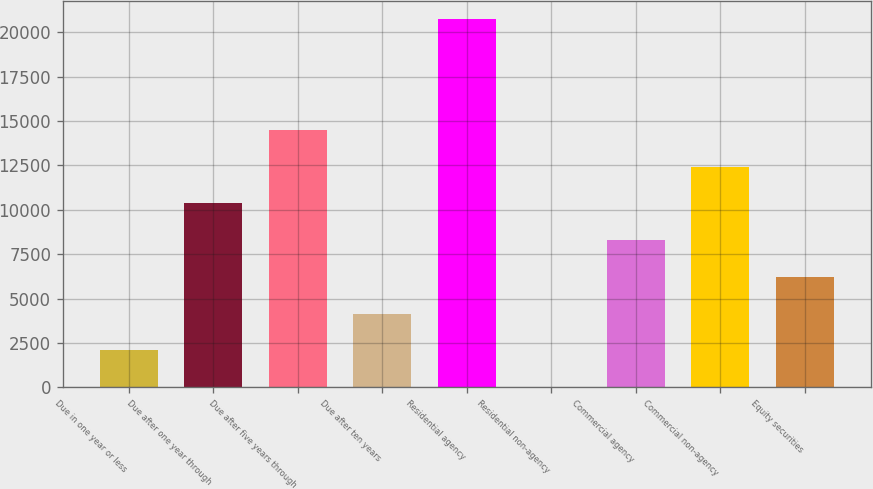Convert chart. <chart><loc_0><loc_0><loc_500><loc_500><bar_chart><fcel>Due in one year or less<fcel>Due after one year through<fcel>Due after five years through<fcel>Due after ten years<fcel>Residential agency<fcel>Residential non-agency<fcel>Commercial agency<fcel>Commercial non-agency<fcel>Equity securities<nl><fcel>2082.9<fcel>10366.5<fcel>14508.3<fcel>4153.8<fcel>20721<fcel>12<fcel>8295.6<fcel>12437.4<fcel>6224.7<nl></chart> 